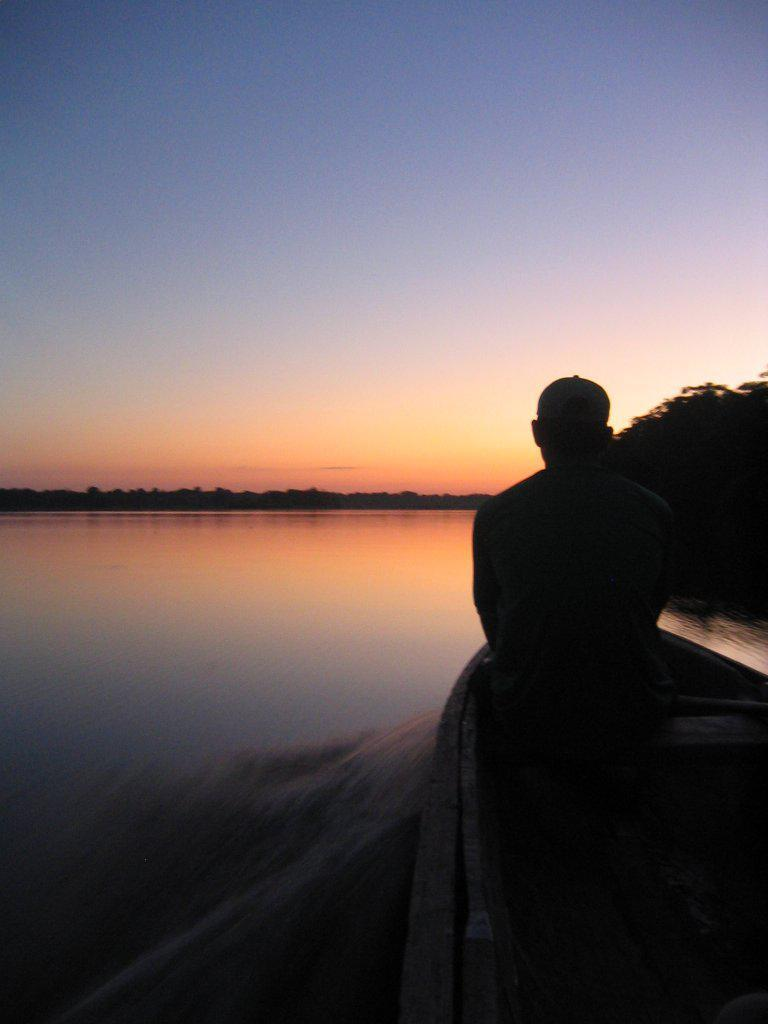What type of water body is present in the image? There is a river in the image. What is on the river in the image? There is a boat on the river. Who or what is in the boat? A person is sitting in the boat. What can be seen in the background of the image? There are trees and the sky visible in the background of the image. Where is the map located in the image? There is no map present in the image. What type of slave is depicted in the image? There is no slave depicted in the image; it features a person sitting in a boat on a river. 